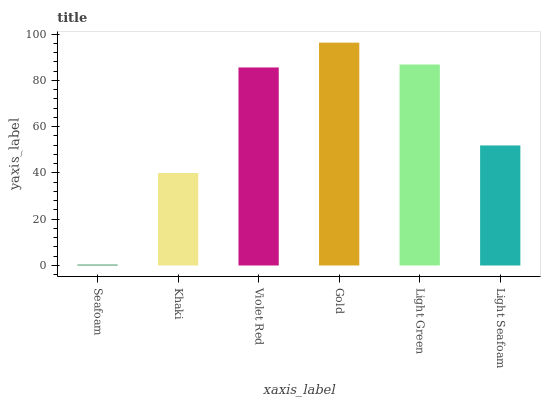Is Seafoam the minimum?
Answer yes or no. Yes. Is Gold the maximum?
Answer yes or no. Yes. Is Khaki the minimum?
Answer yes or no. No. Is Khaki the maximum?
Answer yes or no. No. Is Khaki greater than Seafoam?
Answer yes or no. Yes. Is Seafoam less than Khaki?
Answer yes or no. Yes. Is Seafoam greater than Khaki?
Answer yes or no. No. Is Khaki less than Seafoam?
Answer yes or no. No. Is Violet Red the high median?
Answer yes or no. Yes. Is Light Seafoam the low median?
Answer yes or no. Yes. Is Light Green the high median?
Answer yes or no. No. Is Seafoam the low median?
Answer yes or no. No. 